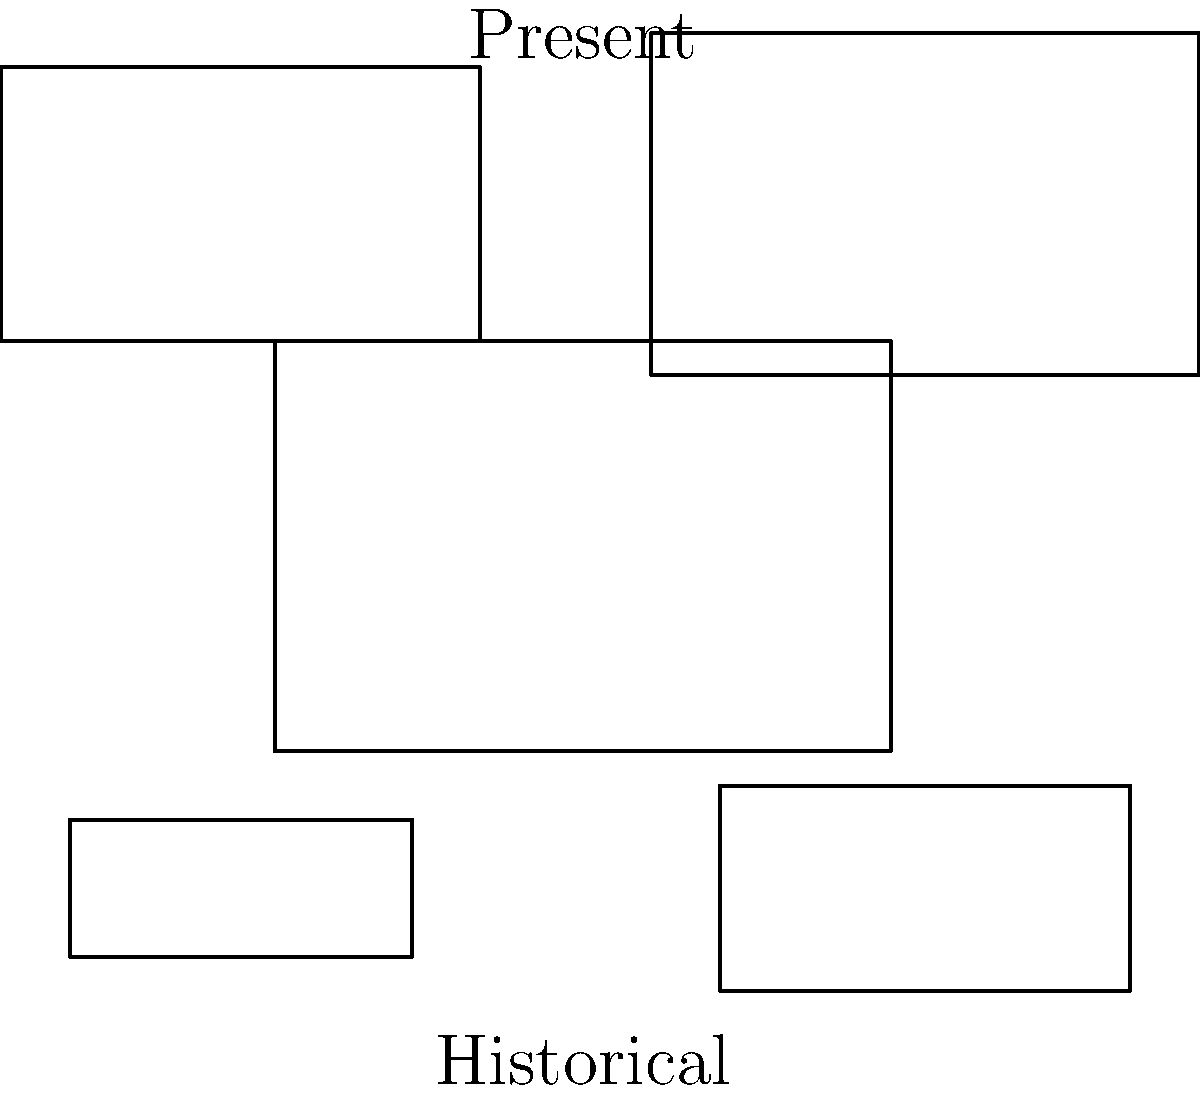In the context of historical documentaries, analyze the montage composition depicted in the graphic. How does this visual representation reflect the typical use of archival footage in relation to the present-day narrative, and what challenges might filmmakers face when integrating such footage? 1. Montage Composition Analysis:
   - The graphic shows a montage of frames decreasing in size from the center outwards.
   - The vertical axis represents time, with "Historical" at the bottom and "Present" at the top.
   - The horizontal axis represents the integration of "Archival Footage" into the documentary timeline.

2. Representation of Archival Footage Use:
   - The largest frame at the center symbolizes the main narrative or present-day context.
   - Smaller frames represent archival footage, suggesting their supportive role in the documentary.
   - The arrangement implies a non-linear approach to storytelling, with archival footage interspersed throughout.

3. Relationship to Present-day Narrative:
   - Archival footage frames surround the central frame, indicating how historical material contextualizes and enriches the present-day story.
   - The varying sizes of frames suggest different emphasis or screen time given to different archival elements.

4. Challenges for Filmmakers:
   a. Contextual Integration: Ensuring seamless integration of archival footage into the modern narrative.
   b. Visual Consistency: Maintaining visual coherence between archival and contemporary footage.
   c. Authenticity: Verifying the authenticity and accuracy of archival materials.
   d. Copyright and Licensing: Obtaining necessary rights for using archival footage.
   e. Technical Quality: Dealing with potential quality issues in older footage.
   f. Narrative Balance: Striking a balance between historical context and present-day relevance.

5. Significance in Documentary Filmmaking:
   - This montage approach allows filmmakers to create a dynamic interplay between past and present.
   - It enables a multi-layered narrative that can provide both historical depth and contemporary relevance.

6. Ethical Considerations:
   - Filmmakers must consider the ethical implications of using and potentially recontextualizing historical footage.
   - There's a responsibility to accurately represent historical events while serving the documentary's narrative goals.
Answer: Non-linear integration of archival footage to contextualize present-day narrative, presenting challenges in seamless integration, visual consistency, authenticity, rights management, and ethical representation. 